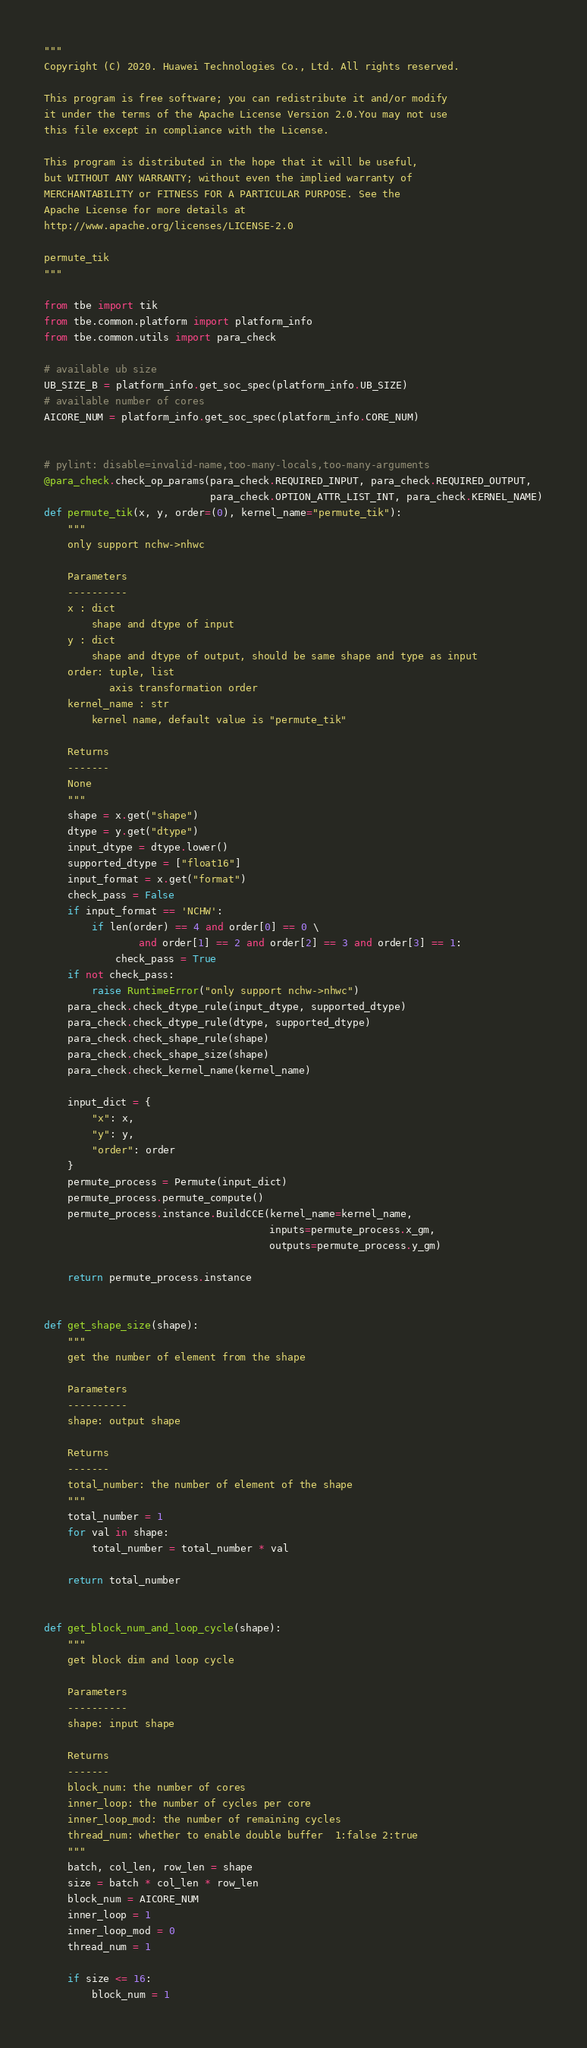<code> <loc_0><loc_0><loc_500><loc_500><_Python_>"""
Copyright (C) 2020. Huawei Technologies Co., Ltd. All rights reserved.

This program is free software; you can redistribute it and/or modify
it under the terms of the Apache License Version 2.0.You may not use
this file except in compliance with the License.

This program is distributed in the hope that it will be useful,
but WITHOUT ANY WARRANTY; without even the implied warranty of
MERCHANTABILITY or FITNESS FOR A PARTICULAR PURPOSE. See the
Apache License for more details at
http://www.apache.org/licenses/LICENSE-2.0

permute_tik
"""

from tbe import tik
from tbe.common.platform import platform_info
from tbe.common.utils import para_check

# available ub size
UB_SIZE_B = platform_info.get_soc_spec(platform_info.UB_SIZE)
# available number of cores
AICORE_NUM = platform_info.get_soc_spec(platform_info.CORE_NUM)


# pylint: disable=invalid-name,too-many-locals,too-many-arguments
@para_check.check_op_params(para_check.REQUIRED_INPUT, para_check.REQUIRED_OUTPUT,
                            para_check.OPTION_ATTR_LIST_INT, para_check.KERNEL_NAME)
def permute_tik(x, y, order=(0), kernel_name="permute_tik"):
    """
    only support nchw->nhwc

    Parameters
    ----------
    x : dict
        shape and dtype of input
    y : dict
        shape and dtype of output, should be same shape and type as input
    order: tuple, list
           axis transformation order
    kernel_name : str
        kernel name, default value is "permute_tik"

    Returns
    -------
    None
    """
    shape = x.get("shape")
    dtype = y.get("dtype")
    input_dtype = dtype.lower()
    supported_dtype = ["float16"]
    input_format = x.get("format")
    check_pass = False
    if input_format == 'NCHW':
        if len(order) == 4 and order[0] == 0 \
                and order[1] == 2 and order[2] == 3 and order[3] == 1:
            check_pass = True
    if not check_pass:
        raise RuntimeError("only support nchw->nhwc")
    para_check.check_dtype_rule(input_dtype, supported_dtype)
    para_check.check_dtype_rule(dtype, supported_dtype)
    para_check.check_shape_rule(shape)
    para_check.check_shape_size(shape)
    para_check.check_kernel_name(kernel_name)

    input_dict = {
        "x": x,
        "y": y,
        "order": order
    }
    permute_process = Permute(input_dict)
    permute_process.permute_compute()
    permute_process.instance.BuildCCE(kernel_name=kernel_name,
                                      inputs=permute_process.x_gm,
                                      outputs=permute_process.y_gm)

    return permute_process.instance


def get_shape_size(shape):
    """
    get the number of element from the shape

    Parameters
    ----------
    shape: output shape

    Returns
    -------
    total_number: the number of element of the shape
    """
    total_number = 1
    for val in shape:
        total_number = total_number * val

    return total_number


def get_block_num_and_loop_cycle(shape):
    """
    get block dim and loop cycle

    Parameters
    ----------
    shape: input shape

    Returns
    -------
    block_num: the number of cores
    inner_loop: the number of cycles per core
    inner_loop_mod: the number of remaining cycles
    thread_num: whether to enable double buffer  1:false 2:true
    """
    batch, col_len, row_len = shape
    size = batch * col_len * row_len
    block_num = AICORE_NUM
    inner_loop = 1
    inner_loop_mod = 0
    thread_num = 1

    if size <= 16:
        block_num = 1</code> 